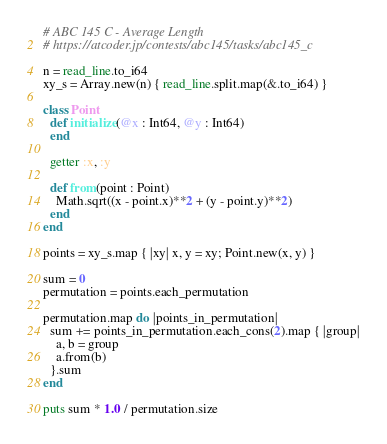<code> <loc_0><loc_0><loc_500><loc_500><_Crystal_># ABC 145 C - Average Length
# https://atcoder.jp/contests/abc145/tasks/abc145_c

n = read_line.to_i64
xy_s = Array.new(n) { read_line.split.map(&.to_i64) }

class Point
  def initialize(@x : Int64, @y : Int64)
  end

  getter :x, :y

  def from(point : Point)
    Math.sqrt((x - point.x)**2 + (y - point.y)**2)
  end
end

points = xy_s.map { |xy| x, y = xy; Point.new(x, y) }

sum = 0
permutation = points.each_permutation

permutation.map do |points_in_permutation|
  sum += points_in_permutation.each_cons(2).map { |group|
    a, b = group
    a.from(b)
  }.sum
end

puts sum * 1.0 / permutation.size
</code> 